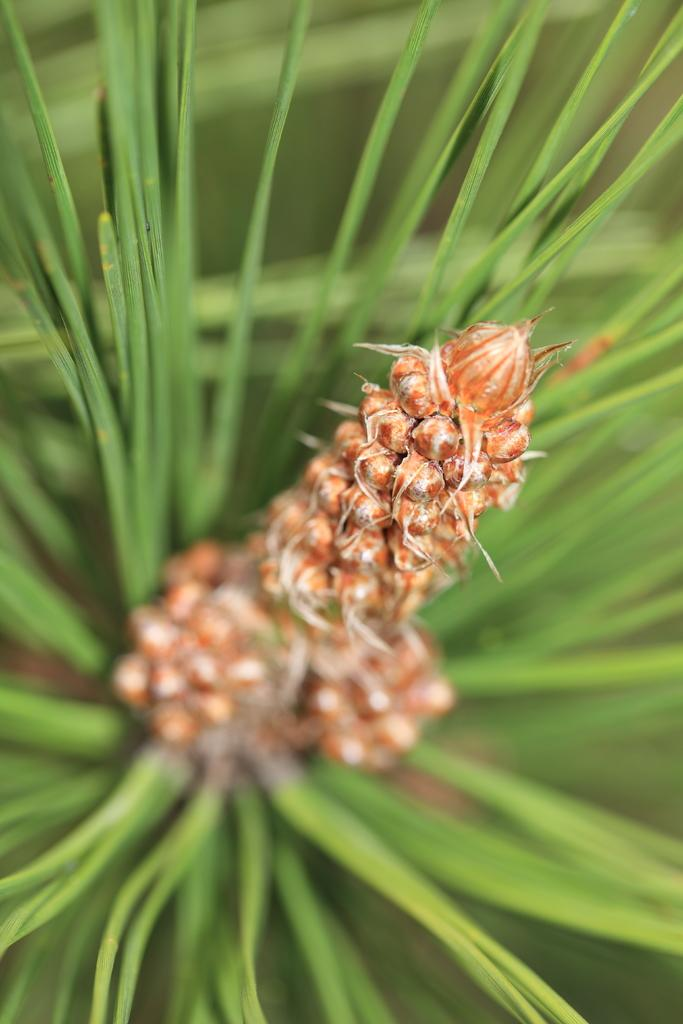What is present in the image? There is a plant in the image. Can you describe the colors of the plant? The plant has brown and green colors. Is there a throne made of leaves in the image? No, there is no throne present in the image. 